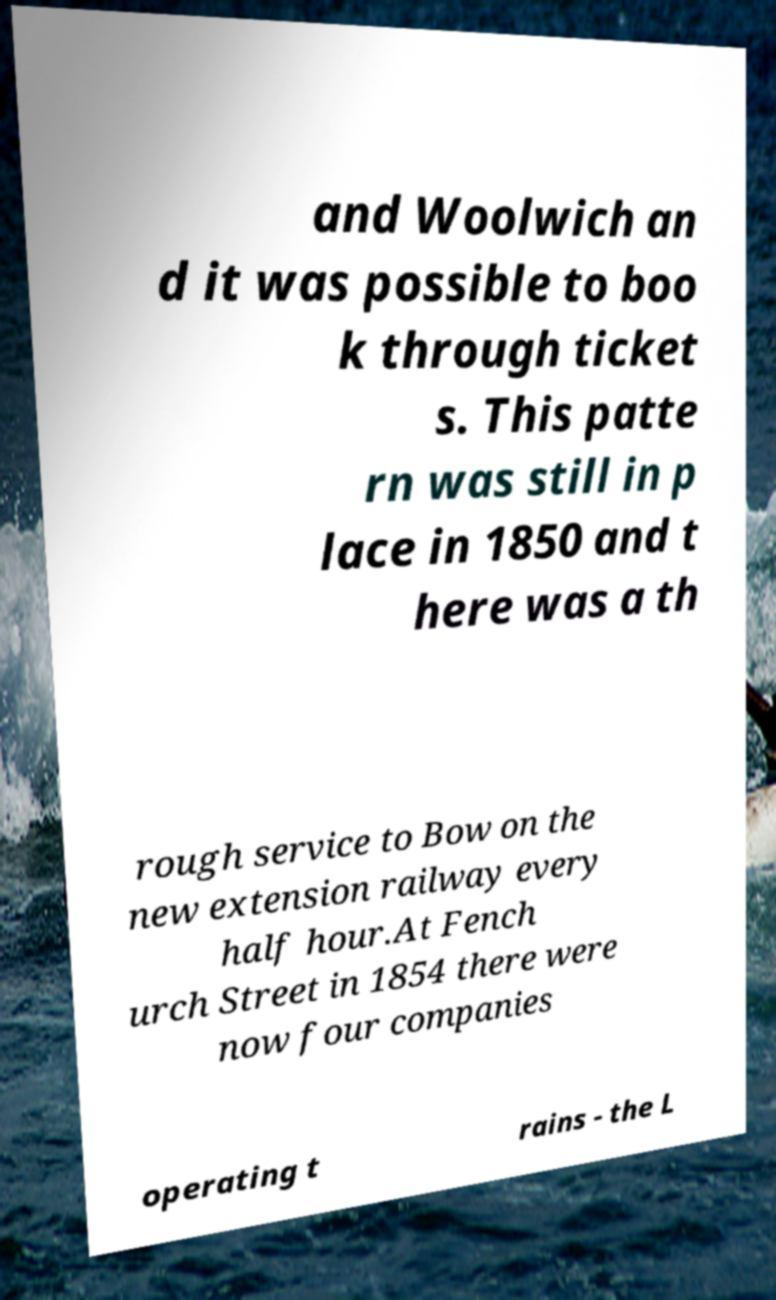Can you accurately transcribe the text from the provided image for me? and Woolwich an d it was possible to boo k through ticket s. This patte rn was still in p lace in 1850 and t here was a th rough service to Bow on the new extension railway every half hour.At Fench urch Street in 1854 there were now four companies operating t rains - the L 